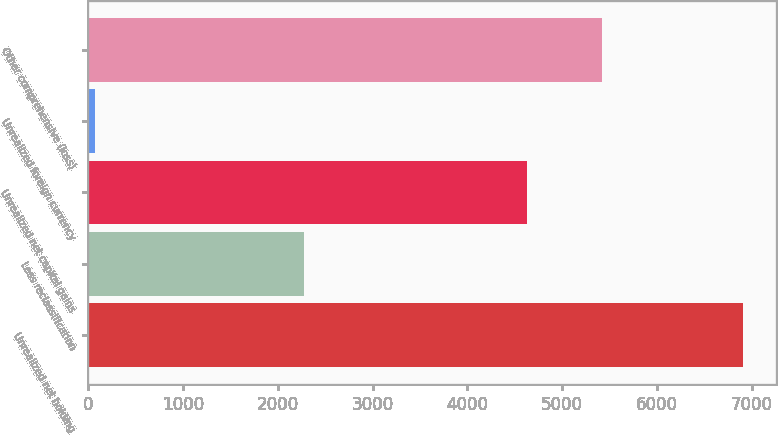Convert chart to OTSL. <chart><loc_0><loc_0><loc_500><loc_500><bar_chart><fcel>Unrealized net holding<fcel>Less reclassification<fcel>Unrealized net capital gains<fcel>Unrealized foreign currency<fcel>Other comprehensive (loss)<nl><fcel>6907<fcel>2281<fcel>4626<fcel>74<fcel>5424<nl></chart> 